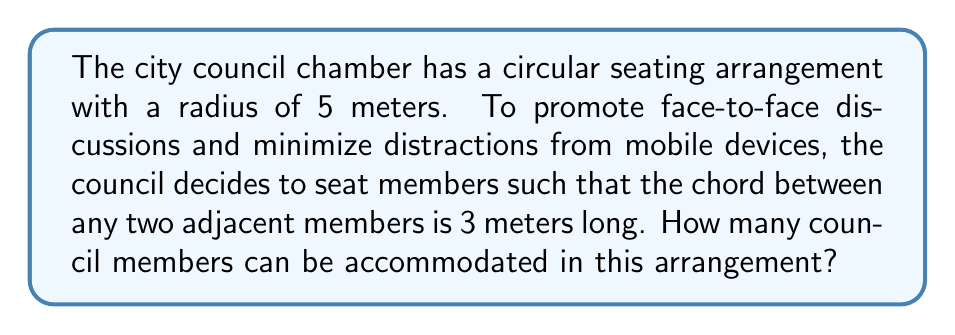Teach me how to tackle this problem. Let's approach this step-by-step:

1) In a circle, the relationship between the central angle $\theta$ (in radians), the radius $r$, and the chord length $c$ is given by:

   $$c = 2r \sin(\frac{\theta}{2})$$

2) We know $r = 5$ meters and $c = 3$ meters. Let's substitute these values:

   $$3 = 2(5) \sin(\frac{\theta}{2})$$

3) Simplify:

   $$\frac{3}{10} = \sin(\frac{\theta}{2})$$

4) Take the inverse sine (arcsin) of both sides:

   $$\frac{\theta}{2} = \arcsin(\frac{3}{10})$$

5) Multiply both sides by 2:

   $$\theta = 2\arcsin(\frac{3}{10})$$

6) Calculate this value (in radians):

   $$\theta \approx 0.6435 \text{ radians}$$

7) The full circle is $2\pi$ radians. To find the number of such angles that fit in a full circle, divide $2\pi$ by $\theta$:

   $$\text{Number of members} = \frac{2\pi}{\theta} = \frac{2\pi}{2\arcsin(\frac{3}{10})} \approx 9.76$$

8) Since we can't have a fractional number of council members, we round down to the nearest whole number.

[asy]
import geometry;

size(200);
pair O = (0,0);
real r = 5;
circle c = circle(O, r);
draw(c);

real theta = 2*asin(3/(2*r));
int n = floor(2*pi/theta);

for(int i = 0; i < n; ++i) {
  pair P = r*dir(i*theta*180/pi);
  dot(P);
}

draw(O--r*dir(0), dashed);
draw(r*dir(0)--r*dir(theta*180/pi));
label("3m", (r*dir(0)+r*dir(theta*180/pi))/2, E);
label("5m", (O+r*dir(theta*180/pi/2))/2, NE);
[/asy]
Answer: 9 council members 